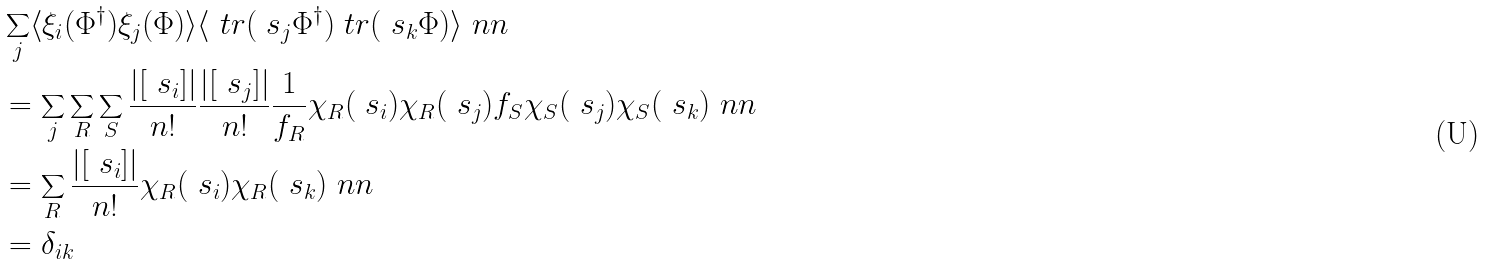Convert formula to latex. <formula><loc_0><loc_0><loc_500><loc_500>& \sum _ { j } \langle \xi _ { i } ( \Phi ^ { \dagger } ) \xi _ { j } ( \Phi ) \rangle \langle \ t r ( \ s _ { j } \Phi ^ { \dagger } ) \ t r ( \ s _ { k } \Phi ) \rangle \ n n \\ & = \sum _ { j } \sum _ { R } \sum _ { S } \frac { | [ \ s _ { i } ] | } { n ! } \frac { | [ \ s _ { j } ] | } { n ! } \frac { 1 } { f _ { R } } \chi _ { R } ( \ s _ { i } ) \chi _ { R } ( \ s _ { j } ) f _ { S } \chi _ { S } ( \ s _ { j } ) \chi _ { S } ( \ s _ { k } ) \ n n \\ & = \sum _ { R } \frac { | [ \ s _ { i } ] | } { n ! } \chi _ { R } ( \ s _ { i } ) \chi _ { R } ( \ s _ { k } ) \ n n \\ & = \delta _ { i k }</formula> 